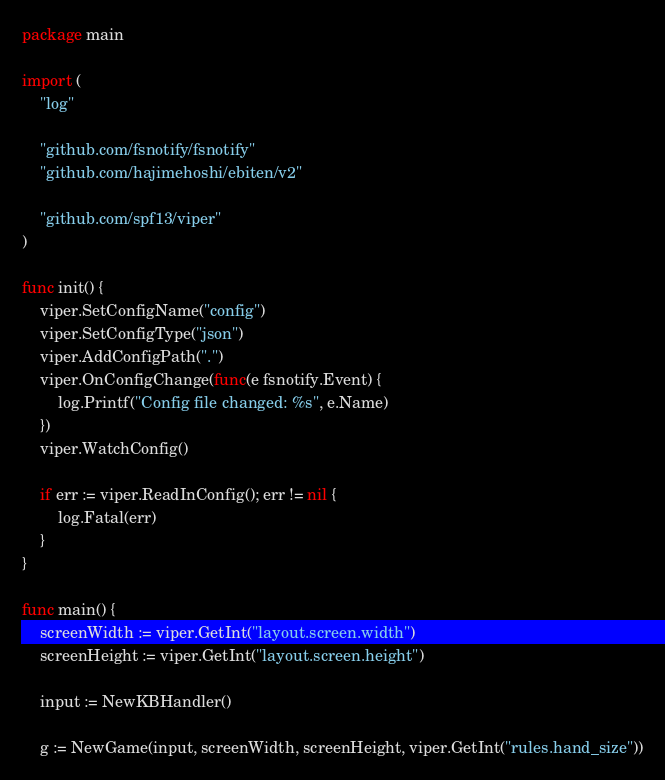<code> <loc_0><loc_0><loc_500><loc_500><_Go_>package main

import (
	"log"

	"github.com/fsnotify/fsnotify"
	"github.com/hajimehoshi/ebiten/v2"

	"github.com/spf13/viper"
)

func init() {
	viper.SetConfigName("config")
	viper.SetConfigType("json")
	viper.AddConfigPath(".")
	viper.OnConfigChange(func(e fsnotify.Event) {
		log.Printf("Config file changed: %s", e.Name)
	})
	viper.WatchConfig()

	if err := viper.ReadInConfig(); err != nil {
		log.Fatal(err)
	}
}

func main() {
	screenWidth := viper.GetInt("layout.screen.width")
	screenHeight := viper.GetInt("layout.screen.height")

	input := NewKBHandler()

	g := NewGame(input, screenWidth, screenHeight, viper.GetInt("rules.hand_size"))
</code> 